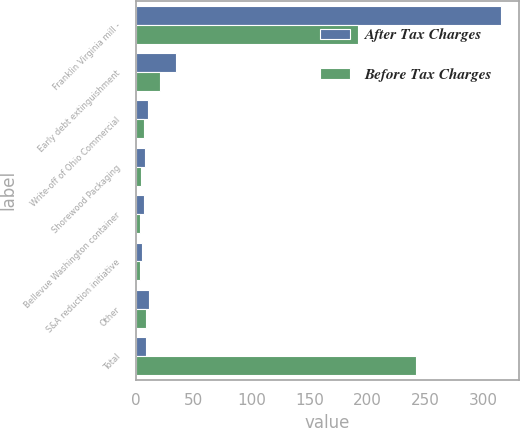<chart> <loc_0><loc_0><loc_500><loc_500><stacked_bar_chart><ecel><fcel>Franklin Virginia mill -<fcel>Early debt extinguishment<fcel>Write-off of Ohio Commercial<fcel>Shorewood Packaging<fcel>Bellevue Washington container<fcel>S&A reduction initiative<fcel>Other<fcel>Total<nl><fcel>After Tax Charges<fcel>315<fcel>35<fcel>11<fcel>8<fcel>7<fcel>6<fcel>12<fcel>9<nl><fcel>Before Tax Charges<fcel>192<fcel>21<fcel>7<fcel>5<fcel>4<fcel>4<fcel>9<fcel>242<nl></chart> 